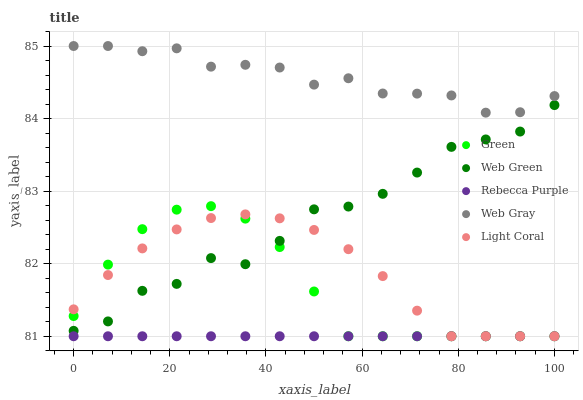Does Rebecca Purple have the minimum area under the curve?
Answer yes or no. Yes. Does Web Gray have the maximum area under the curve?
Answer yes or no. Yes. Does Green have the minimum area under the curve?
Answer yes or no. No. Does Green have the maximum area under the curve?
Answer yes or no. No. Is Rebecca Purple the smoothest?
Answer yes or no. Yes. Is Web Green the roughest?
Answer yes or no. Yes. Is Web Gray the smoothest?
Answer yes or no. No. Is Web Gray the roughest?
Answer yes or no. No. Does Light Coral have the lowest value?
Answer yes or no. Yes. Does Web Gray have the lowest value?
Answer yes or no. No. Does Web Gray have the highest value?
Answer yes or no. Yes. Does Green have the highest value?
Answer yes or no. No. Is Light Coral less than Web Gray?
Answer yes or no. Yes. Is Web Gray greater than Light Coral?
Answer yes or no. Yes. Does Green intersect Web Green?
Answer yes or no. Yes. Is Green less than Web Green?
Answer yes or no. No. Is Green greater than Web Green?
Answer yes or no. No. Does Light Coral intersect Web Gray?
Answer yes or no. No. 